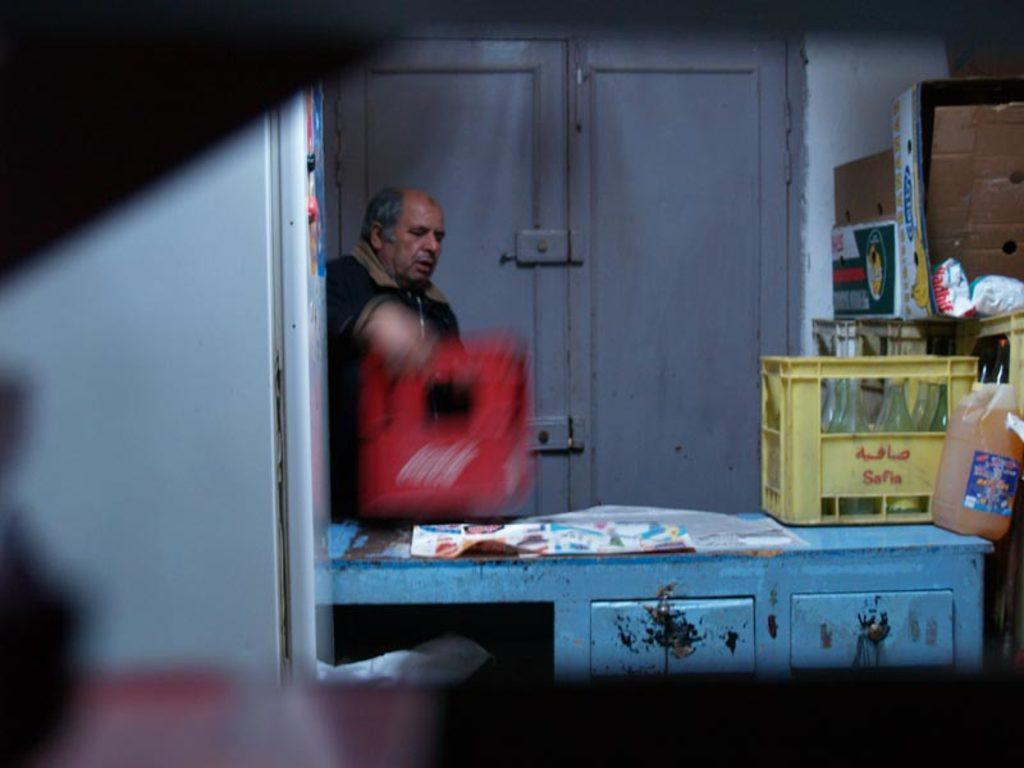What is the main subject of the image? The main subject of the image is a man standing. What objects can be seen in the image besides the man? There are bottles visible in the image. What type of thought is the man having in the image? There is no indication of the man's thoughts in the image. Can you tell me how many experts are present in the image? There is no expert present in the image. Is there a hose visible in the image? There is no hose present in the image. 